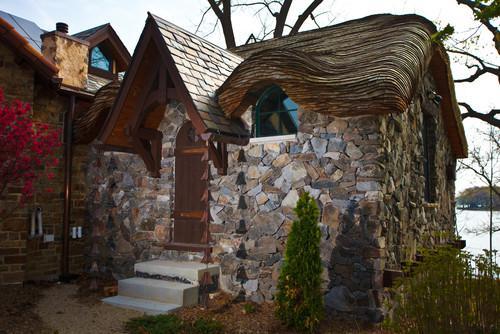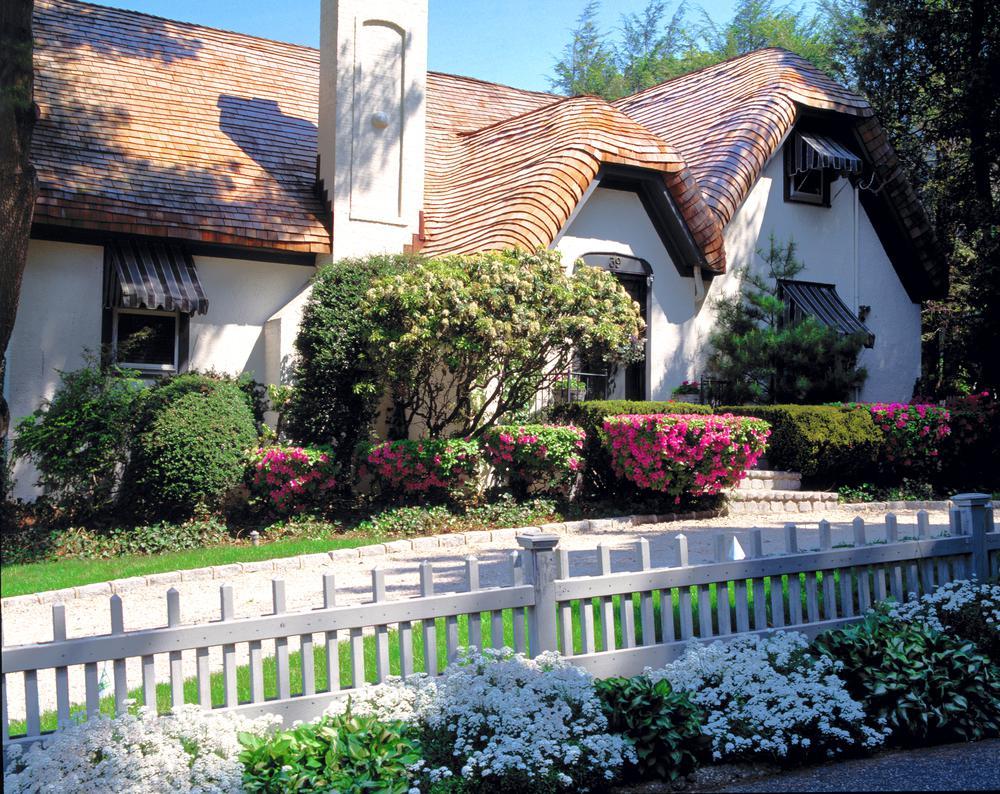The first image is the image on the left, the second image is the image on the right. For the images displayed, is the sentence "there is a home with a thatch roof, fencing and flowers are next to the home" factually correct? Answer yes or no. Yes. 